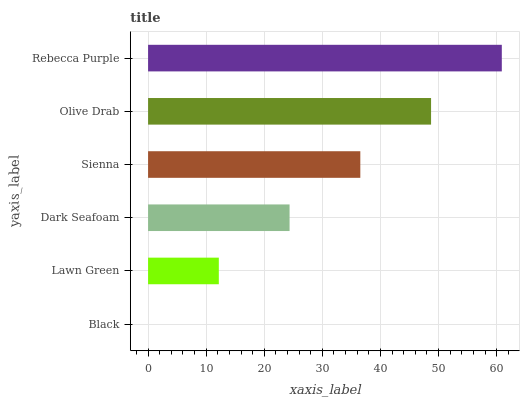Is Black the minimum?
Answer yes or no. Yes. Is Rebecca Purple the maximum?
Answer yes or no. Yes. Is Lawn Green the minimum?
Answer yes or no. No. Is Lawn Green the maximum?
Answer yes or no. No. Is Lawn Green greater than Black?
Answer yes or no. Yes. Is Black less than Lawn Green?
Answer yes or no. Yes. Is Black greater than Lawn Green?
Answer yes or no. No. Is Lawn Green less than Black?
Answer yes or no. No. Is Sienna the high median?
Answer yes or no. Yes. Is Dark Seafoam the low median?
Answer yes or no. Yes. Is Dark Seafoam the high median?
Answer yes or no. No. Is Lawn Green the low median?
Answer yes or no. No. 